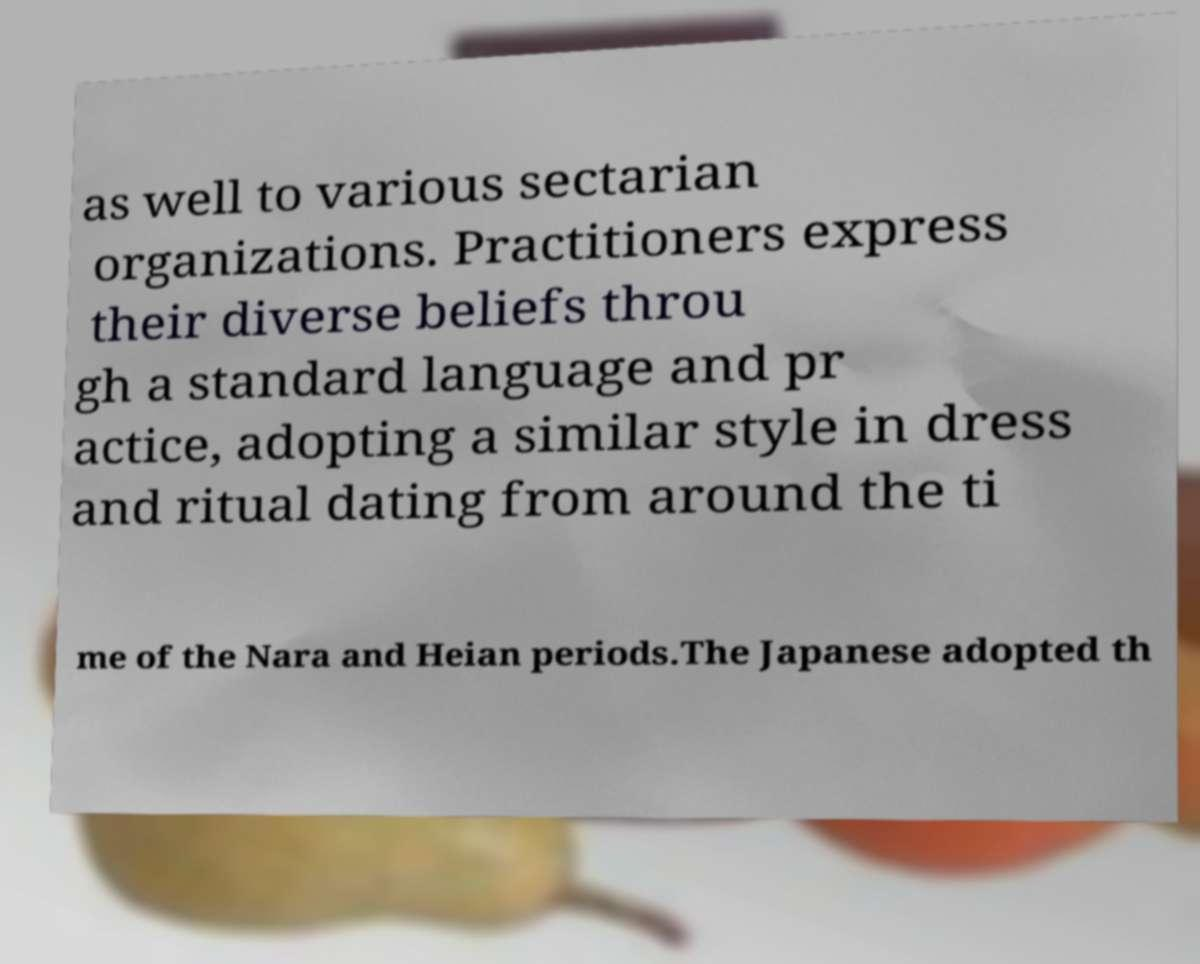For documentation purposes, I need the text within this image transcribed. Could you provide that? as well to various sectarian organizations. Practitioners express their diverse beliefs throu gh a standard language and pr actice, adopting a similar style in dress and ritual dating from around the ti me of the Nara and Heian periods.The Japanese adopted th 